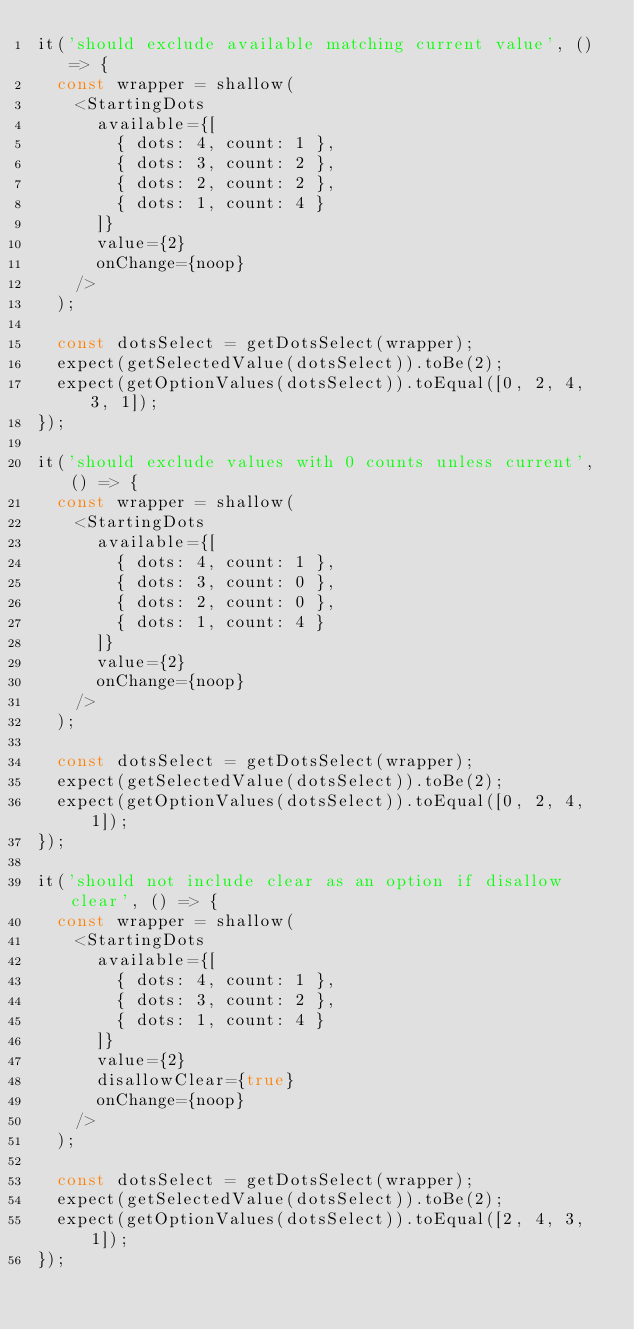Convert code to text. <code><loc_0><loc_0><loc_500><loc_500><_JavaScript_>it('should exclude available matching current value', () => {
  const wrapper = shallow(
    <StartingDots
      available={[
        { dots: 4, count: 1 },
        { dots: 3, count: 2 },
        { dots: 2, count: 2 },
        { dots: 1, count: 4 }
      ]}
      value={2}
      onChange={noop}
    />
  );

  const dotsSelect = getDotsSelect(wrapper);
  expect(getSelectedValue(dotsSelect)).toBe(2);
  expect(getOptionValues(dotsSelect)).toEqual([0, 2, 4, 3, 1]);
});

it('should exclude values with 0 counts unless current', () => {
  const wrapper = shallow(
    <StartingDots
      available={[
        { dots: 4, count: 1 },
        { dots: 3, count: 0 },
        { dots: 2, count: 0 },
        { dots: 1, count: 4 }
      ]}
      value={2}
      onChange={noop}
    />
  );

  const dotsSelect = getDotsSelect(wrapper);
  expect(getSelectedValue(dotsSelect)).toBe(2);
  expect(getOptionValues(dotsSelect)).toEqual([0, 2, 4, 1]);
});

it('should not include clear as an option if disallow clear', () => {
  const wrapper = shallow(
    <StartingDots
      available={[
        { dots: 4, count: 1 },
        { dots: 3, count: 2 },
        { dots: 1, count: 4 }
      ]}
      value={2}
      disallowClear={true}
      onChange={noop}
    />
  );

  const dotsSelect = getDotsSelect(wrapper);
  expect(getSelectedValue(dotsSelect)).toBe(2);
  expect(getOptionValues(dotsSelect)).toEqual([2, 4, 3, 1]);
});
</code> 